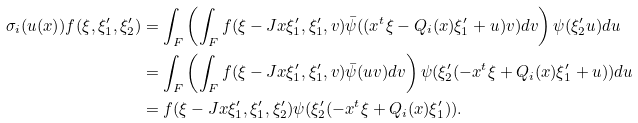Convert formula to latex. <formula><loc_0><loc_0><loc_500><loc_500>\sigma _ { i } ( u ( x ) ) f ( \xi , \xi ^ { \prime } _ { 1 } , \xi ^ { \prime } _ { 2 } ) & = \int _ { F } \left ( \int _ { F } f ( \xi - J x \xi _ { 1 } ^ { \prime } , \xi _ { 1 } ^ { \prime } , v ) \bar { \psi } ( ( x ^ { t } \xi - Q _ { i } ( x ) \xi ^ { \prime } _ { 1 } + u ) v ) d v \right ) \psi ( \xi _ { 2 } ^ { \prime } u ) d u \\ & = \int _ { F } \left ( \int _ { F } f ( \xi - J x \xi _ { 1 } ^ { \prime } , \xi _ { 1 } ^ { \prime } , v ) \bar { \psi } ( u v ) d v \right ) \psi ( \xi _ { 2 } ^ { \prime } ( - x ^ { t } \xi + Q _ { i } ( x ) \xi ^ { \prime } _ { 1 } + u ) ) d u \\ & = f ( \xi - J x \xi _ { 1 } ^ { \prime } , \xi _ { 1 } ^ { \prime } , \xi ^ { \prime } _ { 2 } ) \psi ( \xi _ { 2 } ^ { \prime } ( - x ^ { t } \xi + Q _ { i } ( x ) \xi ^ { \prime } _ { 1 } ) ) .</formula> 